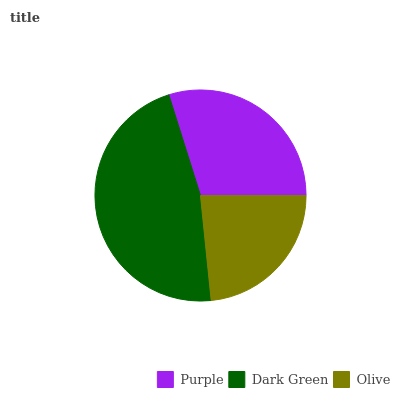Is Olive the minimum?
Answer yes or no. Yes. Is Dark Green the maximum?
Answer yes or no. Yes. Is Dark Green the minimum?
Answer yes or no. No. Is Olive the maximum?
Answer yes or no. No. Is Dark Green greater than Olive?
Answer yes or no. Yes. Is Olive less than Dark Green?
Answer yes or no. Yes. Is Olive greater than Dark Green?
Answer yes or no. No. Is Dark Green less than Olive?
Answer yes or no. No. Is Purple the high median?
Answer yes or no. Yes. Is Purple the low median?
Answer yes or no. Yes. Is Dark Green the high median?
Answer yes or no. No. Is Dark Green the low median?
Answer yes or no. No. 